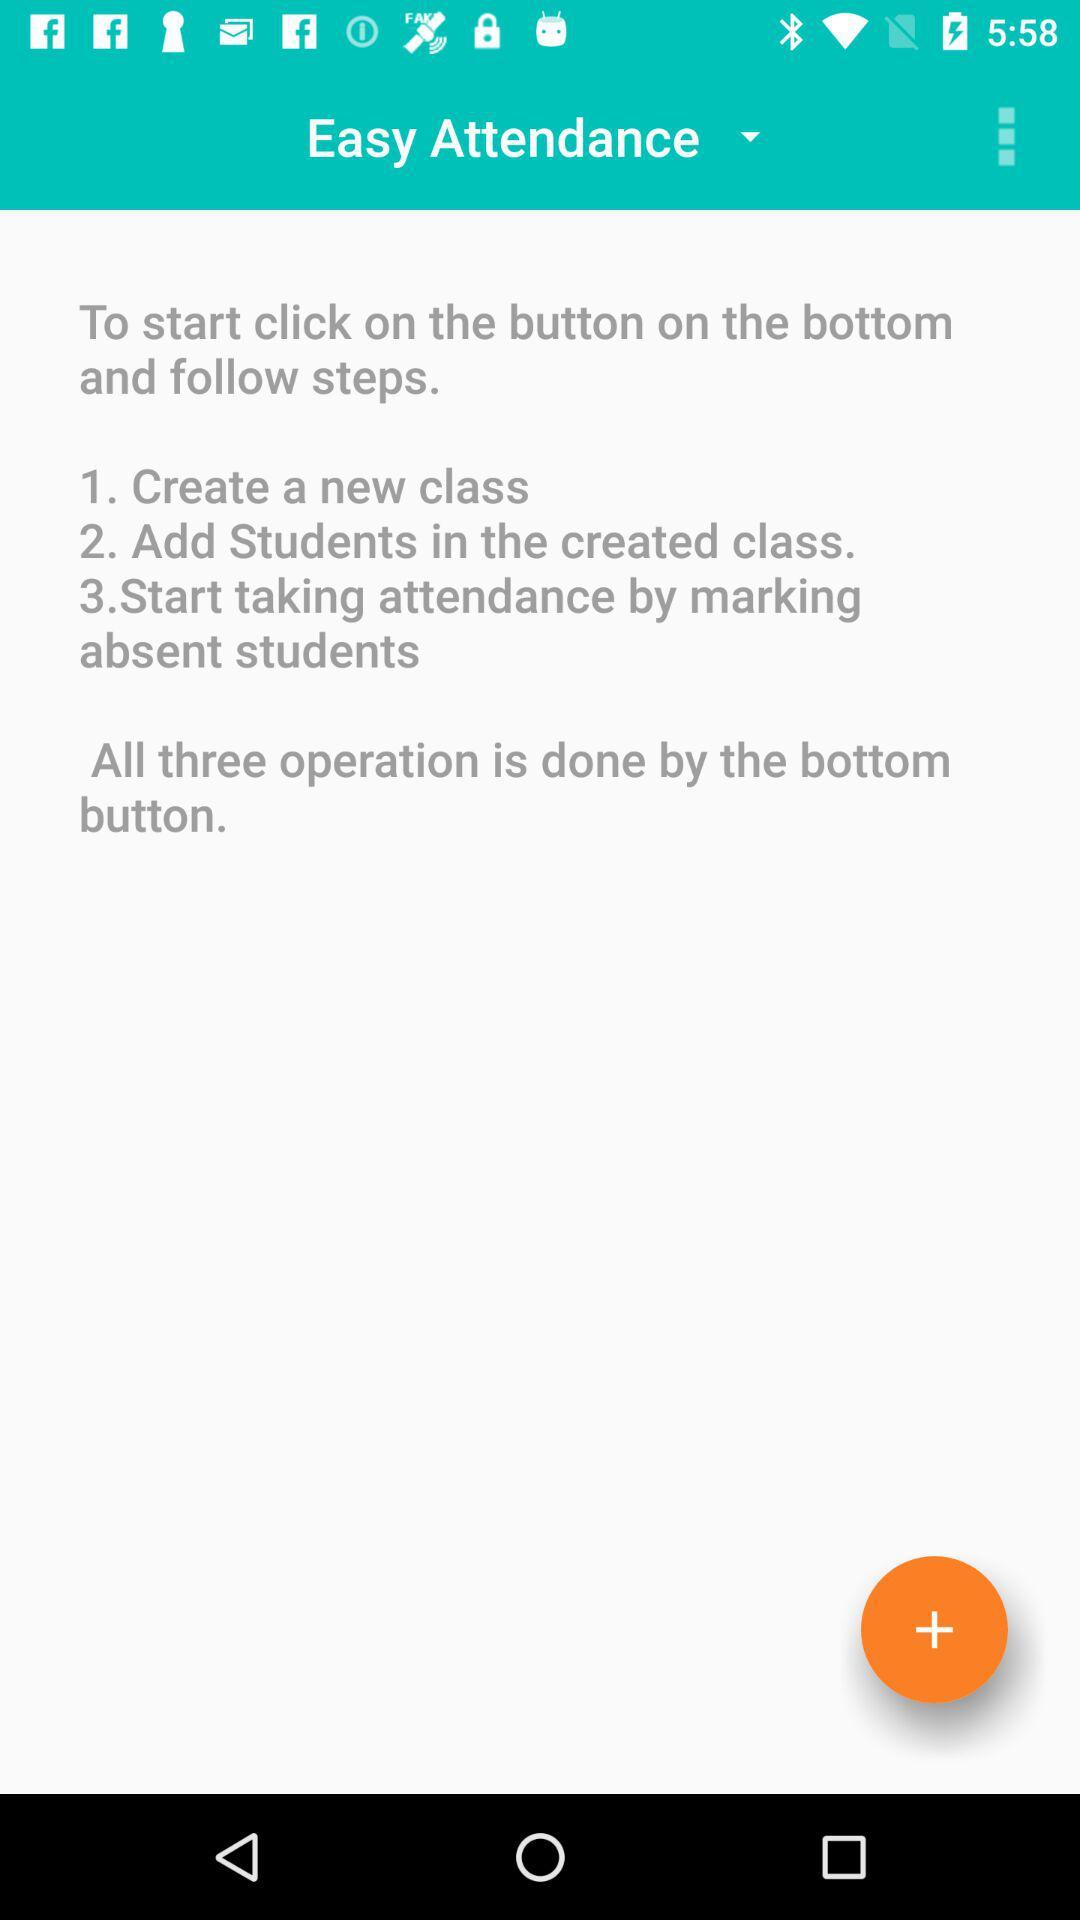How many steps are there in the process of taking attendance?
Answer the question using a single word or phrase. 3 